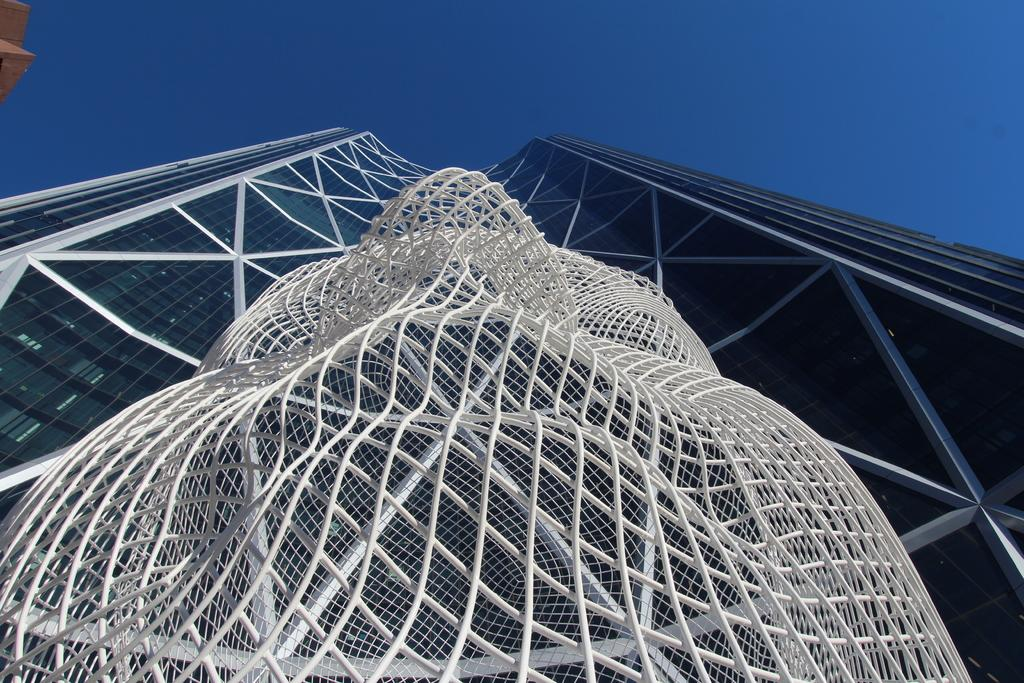What type of structure is visible in the picture? There is a building in the picture. Can you describe any specific architectural features in the picture? Yes, there is an architectural feature in the picture. What color is the sky in the picture? The sky is blue in the picture. What type of treatment is being administered to the building in the picture? There is no indication in the image that any treatment is being administered to the building. In which direction is the building facing in the picture? The direction the building is facing cannot be determined from the image alone. 